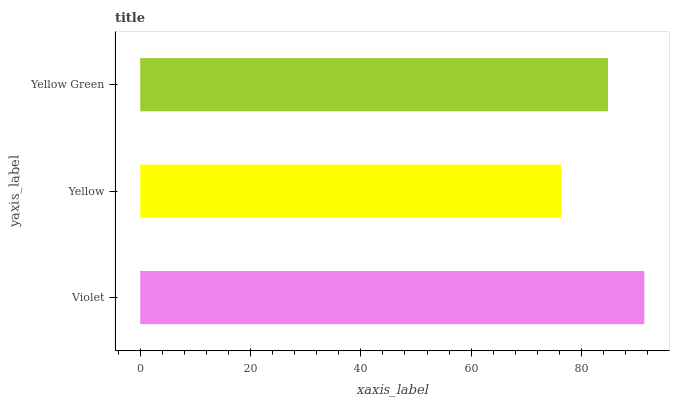Is Yellow the minimum?
Answer yes or no. Yes. Is Violet the maximum?
Answer yes or no. Yes. Is Yellow Green the minimum?
Answer yes or no. No. Is Yellow Green the maximum?
Answer yes or no. No. Is Yellow Green greater than Yellow?
Answer yes or no. Yes. Is Yellow less than Yellow Green?
Answer yes or no. Yes. Is Yellow greater than Yellow Green?
Answer yes or no. No. Is Yellow Green less than Yellow?
Answer yes or no. No. Is Yellow Green the high median?
Answer yes or no. Yes. Is Yellow Green the low median?
Answer yes or no. Yes. Is Yellow the high median?
Answer yes or no. No. Is Yellow the low median?
Answer yes or no. No. 